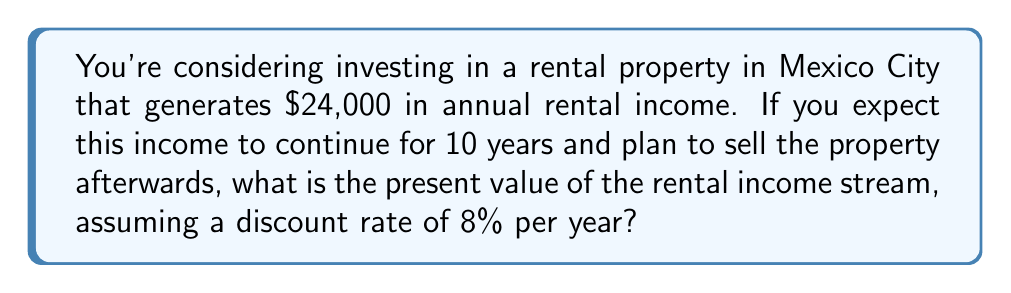Provide a solution to this math problem. To solve this problem, we need to use the present value formula for an annuity. The rental income can be considered as a series of equal payments (an annuity) over 10 years.

The formula for the present value of an annuity is:

$$PV = PMT \cdot \frac{1 - (1 + r)^{-n}}{r}$$

Where:
$PV$ = Present Value
$PMT$ = Payment (annual rental income)
$r$ = Discount rate (as a decimal)
$n$ = Number of years

Given:
$PMT = \$24,000$
$r = 0.08$ (8% as a decimal)
$n = 10$ years

Let's substitute these values into the formula:

$$PV = 24,000 \cdot \frac{1 - (1 + 0.08)^{-10}}{0.08}$$

Now, let's calculate step by step:

1) First, calculate $(1 + 0.08)^{-10}$:
   $$(1.08)^{-10} \approx 0.4632$$

2) Subtract this from 1:
   $$1 - 0.4632 = 0.5368$$

3) Divide by 0.08:
   $$\frac{0.5368}{0.08} = 6.71$$

4) Multiply by 24,000:
   $$24,000 \cdot 6.71 = 161,040$$

Therefore, the present value of the rental income stream is approximately $161,040.
Answer: $161,040 